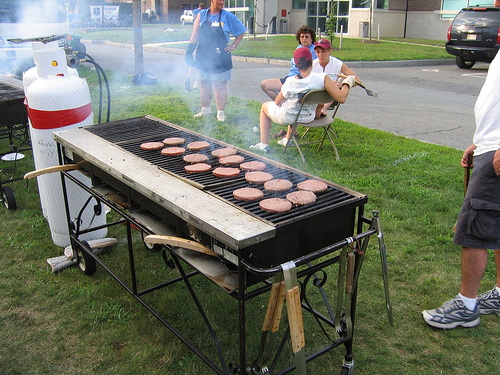<image>
Can you confirm if the burger is on the grill? Yes. Looking at the image, I can see the burger is positioned on top of the grill, with the grill providing support. 